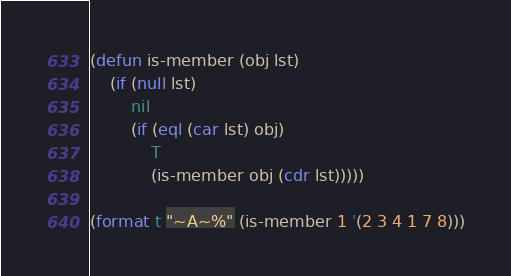Convert code to text. <code><loc_0><loc_0><loc_500><loc_500><_Lisp_>(defun is-member (obj lst)
    (if (null lst)
        nil
        (if (eql (car lst) obj)
            T
            (is-member obj (cdr lst)))))

(format t "~A~%" (is-member 1 '(2 3 4 1 7 8)))
</code> 